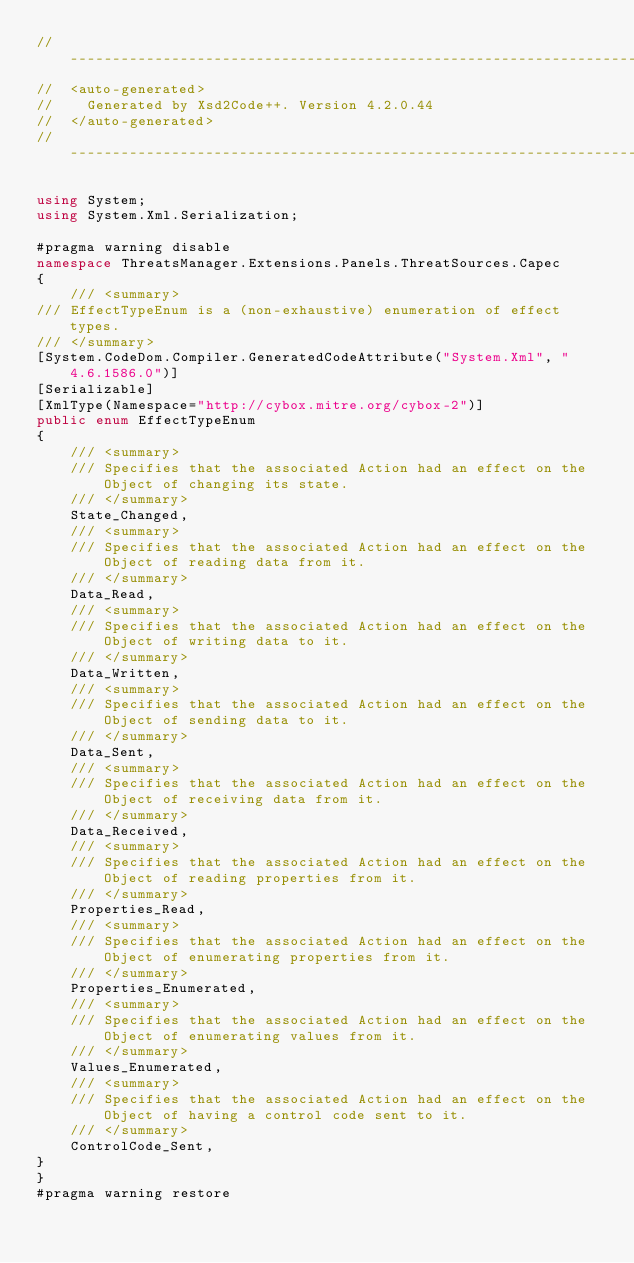Convert code to text. <code><loc_0><loc_0><loc_500><loc_500><_C#_>// ------------------------------------------------------------------------------
//  <auto-generated>
//    Generated by Xsd2Code++. Version 4.2.0.44
//  </auto-generated>
// ------------------------------------------------------------------------------

using System;
using System.Xml.Serialization;

#pragma warning disable
namespace ThreatsManager.Extensions.Panels.ThreatSources.Capec
{
    /// <summary>
/// EffectTypeEnum is a (non-exhaustive) enumeration of effect types.
/// </summary>
[System.CodeDom.Compiler.GeneratedCodeAttribute("System.Xml", "4.6.1586.0")]
[Serializable]
[XmlType(Namespace="http://cybox.mitre.org/cybox-2")]
public enum EffectTypeEnum
{
    /// <summary>
    /// Specifies that the associated Action had an effect on the Object of changing its state.
    /// </summary>
    State_Changed,
    /// <summary>
    /// Specifies that the associated Action had an effect on the Object of reading data from it.
    /// </summary>
    Data_Read,
    /// <summary>
    /// Specifies that the associated Action had an effect on the Object of writing data to it.
    /// </summary>
    Data_Written,
    /// <summary>
    /// Specifies that the associated Action had an effect on the Object of sending data to it.
    /// </summary>
    Data_Sent,
    /// <summary>
    /// Specifies that the associated Action had an effect on the Object of receiving data from it.
    /// </summary>
    Data_Received,
    /// <summary>
    /// Specifies that the associated Action had an effect on the Object of reading properties from it.
    /// </summary>
    Properties_Read,
    /// <summary>
    /// Specifies that the associated Action had an effect on the Object of enumerating properties from it.
    /// </summary>
    Properties_Enumerated,
    /// <summary>
    /// Specifies that the associated Action had an effect on the Object of enumerating values from it.
    /// </summary>
    Values_Enumerated,
    /// <summary>
    /// Specifies that the associated Action had an effect on the Object of having a control code sent to it.
    /// </summary>
    ControlCode_Sent,
}
}
#pragma warning restore
</code> 